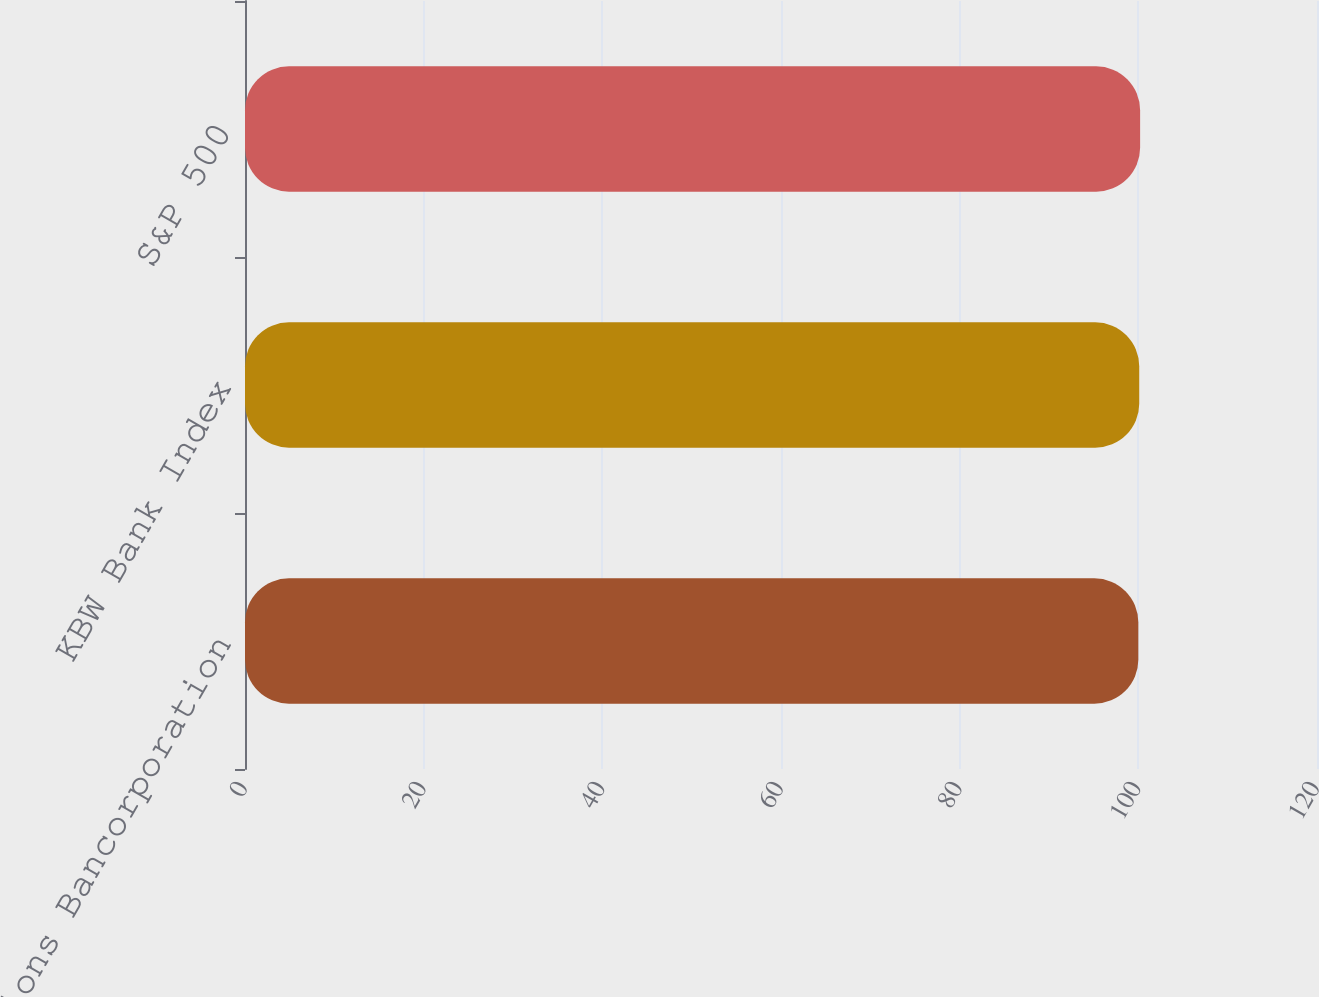Convert chart. <chart><loc_0><loc_0><loc_500><loc_500><bar_chart><fcel>Zions Bancorporation<fcel>KBW Bank Index<fcel>S&P 500<nl><fcel>100<fcel>100.1<fcel>100.2<nl></chart> 